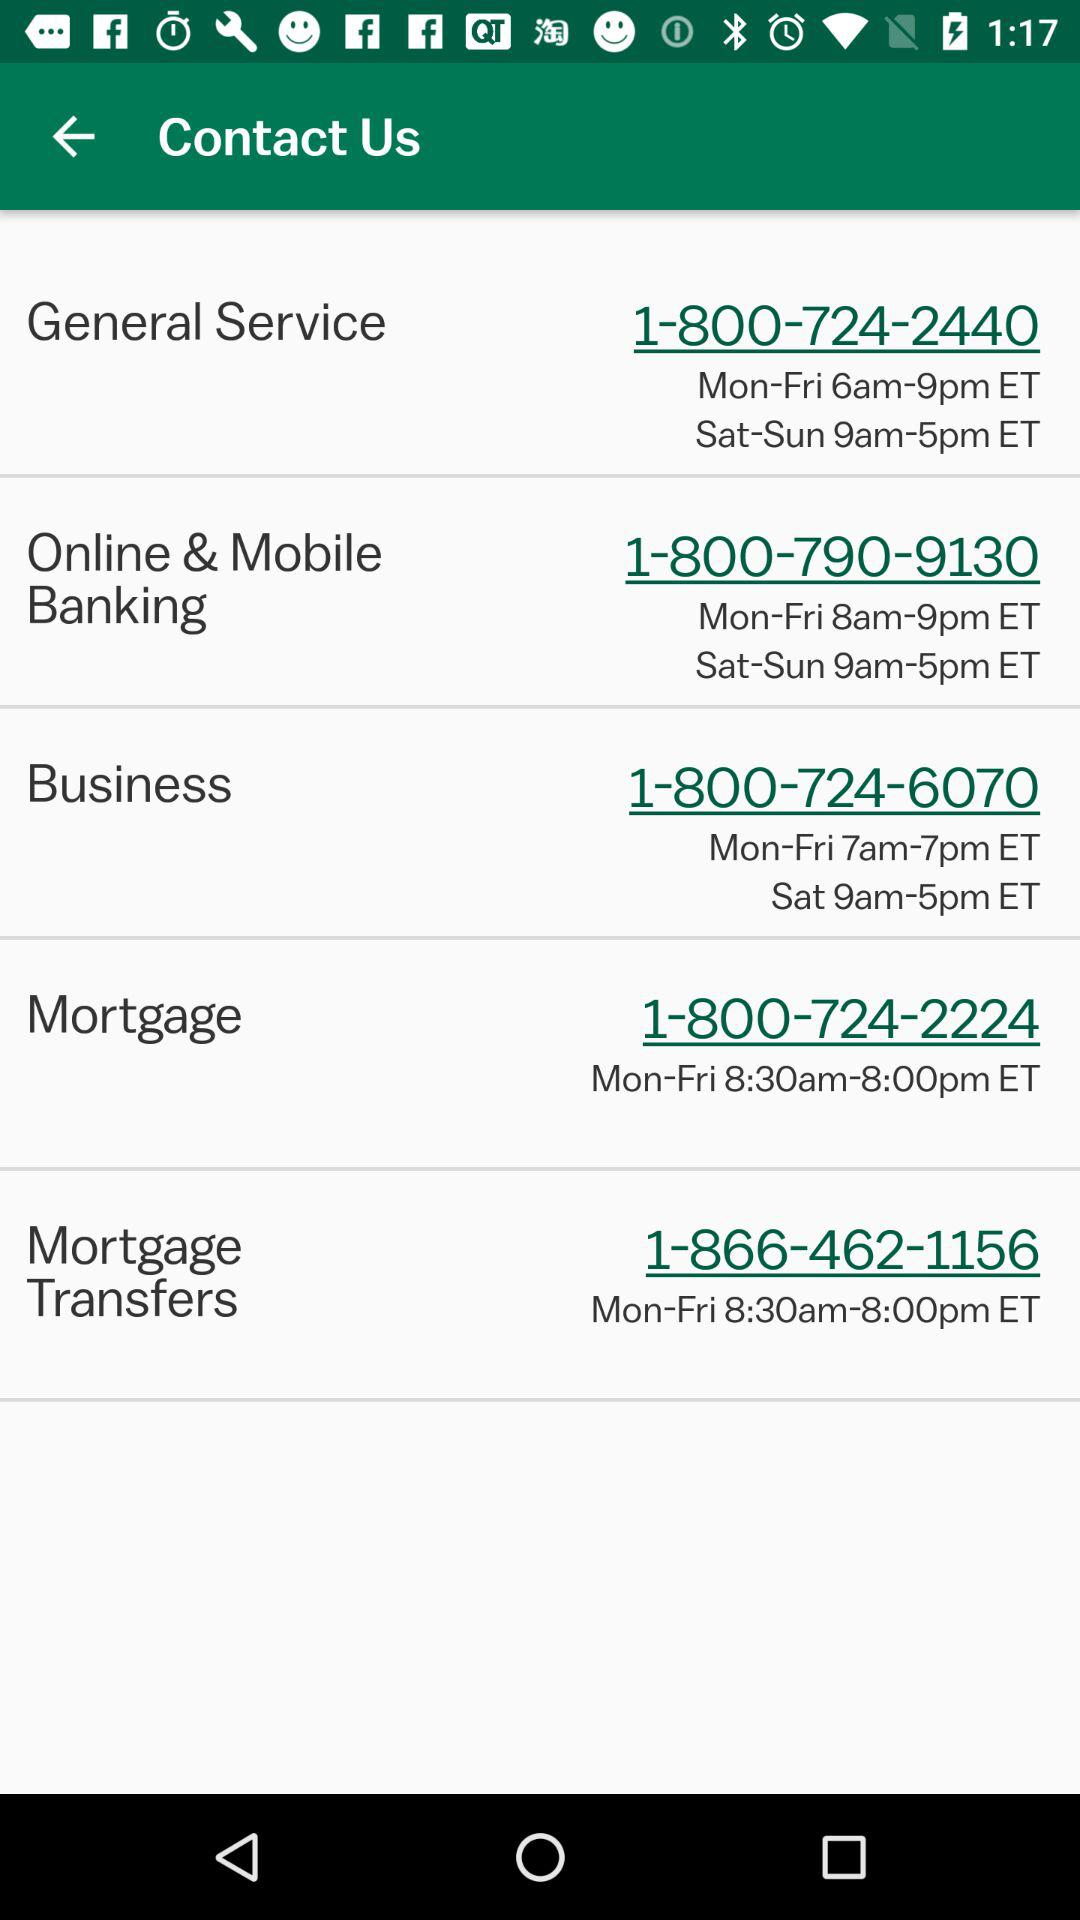What is the time to call in "Mortgage Transfers" from Monday to Friday? The time to call in "Mortgage Transfers" is 8:30am-8:00pm ET. 